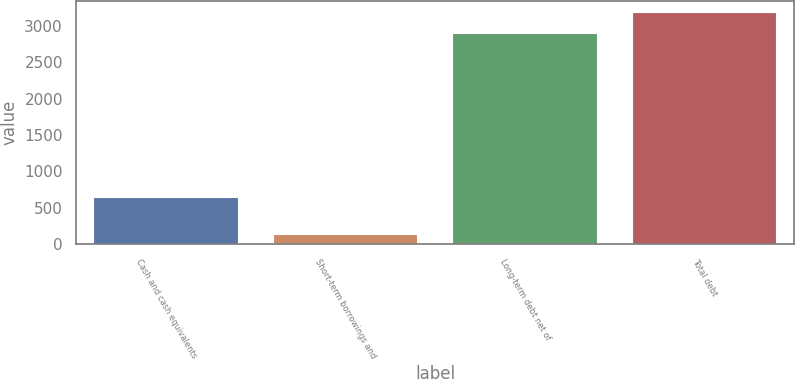Convert chart. <chart><loc_0><loc_0><loc_500><loc_500><bar_chart><fcel>Cash and cash equivalents<fcel>Short-term borrowings and<fcel>Long-term debt net of<fcel>Total debt<nl><fcel>638<fcel>118<fcel>2890<fcel>3179<nl></chart> 